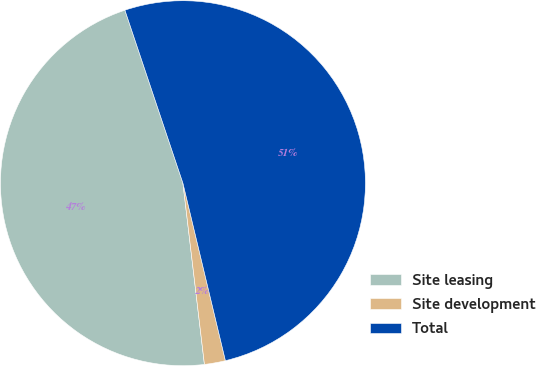Convert chart. <chart><loc_0><loc_0><loc_500><loc_500><pie_chart><fcel>Site leasing<fcel>Site development<fcel>Total<nl><fcel>46.73%<fcel>1.86%<fcel>51.41%<nl></chart> 